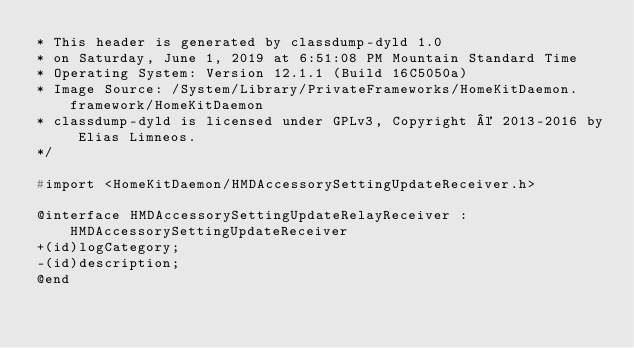Convert code to text. <code><loc_0><loc_0><loc_500><loc_500><_C_>* This header is generated by classdump-dyld 1.0
* on Saturday, June 1, 2019 at 6:51:08 PM Mountain Standard Time
* Operating System: Version 12.1.1 (Build 16C5050a)
* Image Source: /System/Library/PrivateFrameworks/HomeKitDaemon.framework/HomeKitDaemon
* classdump-dyld is licensed under GPLv3, Copyright © 2013-2016 by Elias Limneos.
*/

#import <HomeKitDaemon/HMDAccessorySettingUpdateReceiver.h>

@interface HMDAccessorySettingUpdateRelayReceiver : HMDAccessorySettingUpdateReceiver
+(id)logCategory;
-(id)description;
@end

</code> 